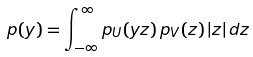Convert formula to latex. <formula><loc_0><loc_0><loc_500><loc_500>p ( y ) = \int _ { - \infty } ^ { \infty } p _ { U } ( y z ) \, p _ { V } ( z ) \, | z | \, d z</formula> 